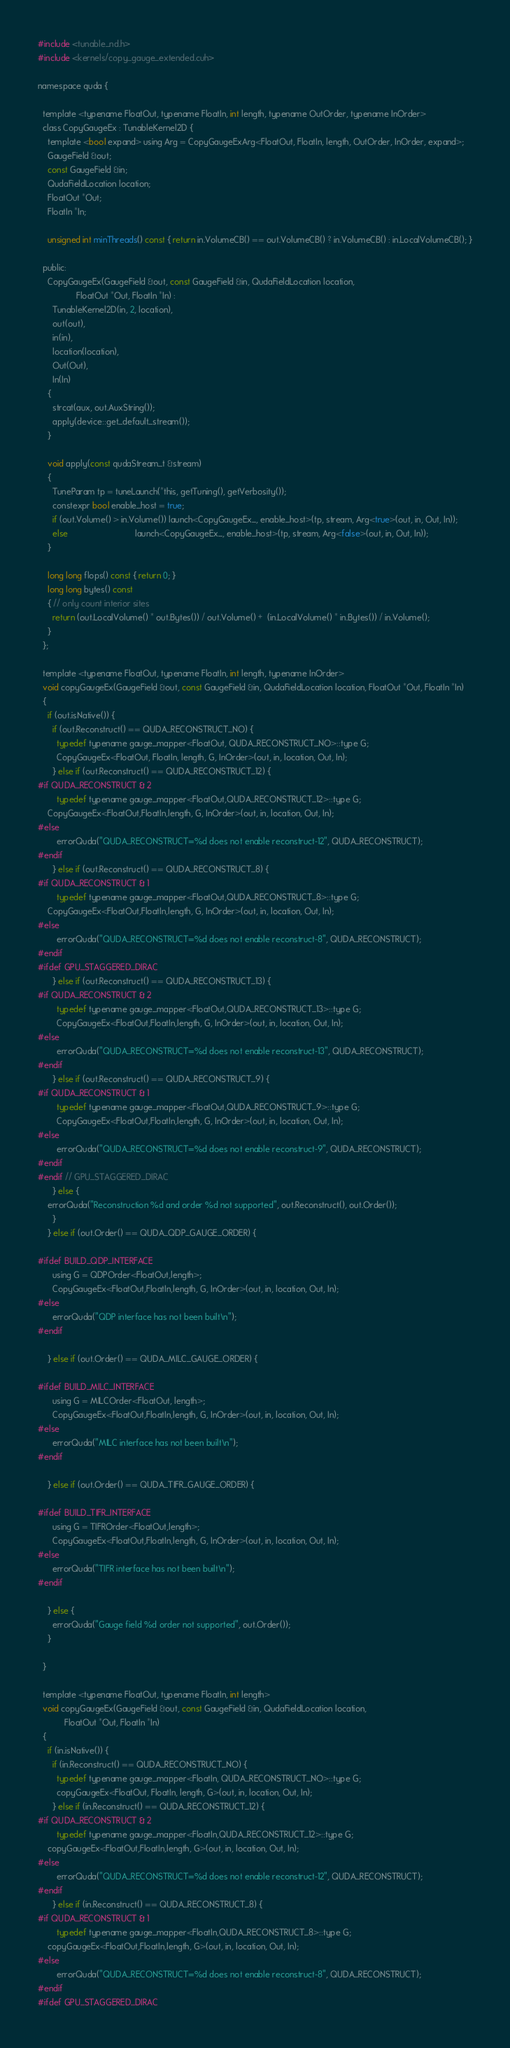Convert code to text. <code><loc_0><loc_0><loc_500><loc_500><_Cuda_>#include <tunable_nd.h>
#include <kernels/copy_gauge_extended.cuh>

namespace quda {

  template <typename FloatOut, typename FloatIn, int length, typename OutOrder, typename InOrder>
  class CopyGaugeEx : TunableKernel2D {
    template <bool expand> using Arg = CopyGaugeExArg<FloatOut, FloatIn, length, OutOrder, InOrder, expand>;
    GaugeField &out;
    const GaugeField &in;
    QudaFieldLocation location;
    FloatOut *Out;
    FloatIn *In;

    unsigned int minThreads() const { return in.VolumeCB() == out.VolumeCB() ? in.VolumeCB() : in.LocalVolumeCB(); }

  public:
    CopyGaugeEx(GaugeField &out, const GaugeField &in, QudaFieldLocation location,
                FloatOut *Out, FloatIn *In) :
      TunableKernel2D(in, 2, location),
      out(out),
      in(in),
      location(location),
      Out(Out),
      In(In)
    {
      strcat(aux, out.AuxString());
      apply(device::get_default_stream());
    }

    void apply(const qudaStream_t &stream)
    {
      TuneParam tp = tuneLaunch(*this, getTuning(), getVerbosity());
      constexpr bool enable_host = true;
      if (out.Volume() > in.Volume()) launch<CopyGaugeEx_, enable_host>(tp, stream, Arg<true>(out, in, Out, In));
      else                            launch<CopyGaugeEx_, enable_host>(tp, stream, Arg<false>(out, in, Out, In));
    }

    long long flops() const { return 0; }
    long long bytes() const
    { // only count interior sites
      return (out.LocalVolume() * out.Bytes()) / out.Volume() +  (in.LocalVolume() * in.Bytes()) / in.Volume();
    }
  };

  template <typename FloatOut, typename FloatIn, int length, typename InOrder>
  void copyGaugeEx(GaugeField &out, const GaugeField &in, QudaFieldLocation location, FloatOut *Out, FloatIn *In)
  {
    if (out.isNative()) {
      if (out.Reconstruct() == QUDA_RECONSTRUCT_NO) {
        typedef typename gauge_mapper<FloatOut, QUDA_RECONSTRUCT_NO>::type G;
        CopyGaugeEx<FloatOut, FloatIn, length, G, InOrder>(out, in, location, Out, In);
      } else if (out.Reconstruct() == QUDA_RECONSTRUCT_12) {
#if QUDA_RECONSTRUCT & 2
        typedef typename gauge_mapper<FloatOut,QUDA_RECONSTRUCT_12>::type G;
	CopyGaugeEx<FloatOut,FloatIn,length, G, InOrder>(out, in, location, Out, In);
#else
        errorQuda("QUDA_RECONSTRUCT=%d does not enable reconstruct-12", QUDA_RECONSTRUCT);
#endif
      } else if (out.Reconstruct() == QUDA_RECONSTRUCT_8) {
#if QUDA_RECONSTRUCT & 1
        typedef typename gauge_mapper<FloatOut,QUDA_RECONSTRUCT_8>::type G;
	CopyGaugeEx<FloatOut,FloatIn,length, G, InOrder>(out, in, location, Out, In);
#else
        errorQuda("QUDA_RECONSTRUCT=%d does not enable reconstruct-8", QUDA_RECONSTRUCT);
#endif
#ifdef GPU_STAGGERED_DIRAC
      } else if (out.Reconstruct() == QUDA_RECONSTRUCT_13) {
#if QUDA_RECONSTRUCT & 2
        typedef typename gauge_mapper<FloatOut,QUDA_RECONSTRUCT_13>::type G;
        CopyGaugeEx<FloatOut,FloatIn,length, G, InOrder>(out, in, location, Out, In);
#else
        errorQuda("QUDA_RECONSTRUCT=%d does not enable reconstruct-13", QUDA_RECONSTRUCT);
#endif
      } else if (out.Reconstruct() == QUDA_RECONSTRUCT_9) {
#if QUDA_RECONSTRUCT & 1
        typedef typename gauge_mapper<FloatOut,QUDA_RECONSTRUCT_9>::type G;
        CopyGaugeEx<FloatOut,FloatIn,length, G, InOrder>(out, in, location, Out, In);
#else
        errorQuda("QUDA_RECONSTRUCT=%d does not enable reconstruct-9", QUDA_RECONSTRUCT);
#endif
#endif // GPU_STAGGERED_DIRAC
      } else {
	errorQuda("Reconstruction %d and order %d not supported", out.Reconstruct(), out.Order());
      }
    } else if (out.Order() == QUDA_QDP_GAUGE_ORDER) {

#ifdef BUILD_QDP_INTERFACE
      using G = QDPOrder<FloatOut,length>;
      CopyGaugeEx<FloatOut,FloatIn,length, G, InOrder>(out, in, location, Out, In);
#else
      errorQuda("QDP interface has not been built\n");
#endif

    } else if (out.Order() == QUDA_MILC_GAUGE_ORDER) {

#ifdef BUILD_MILC_INTERFACE
      using G = MILCOrder<FloatOut, length>;
      CopyGaugeEx<FloatOut,FloatIn,length, G, InOrder>(out, in, location, Out, In);
#else
      errorQuda("MILC interface has not been built\n");
#endif

    } else if (out.Order() == QUDA_TIFR_GAUGE_ORDER) {

#ifdef BUILD_TIFR_INTERFACE
      using G = TIFROrder<FloatOut,length>;
      CopyGaugeEx<FloatOut,FloatIn,length, G, InOrder>(out, in, location, Out, In);
#else
      errorQuda("TIFR interface has not been built\n");
#endif

    } else {
      errorQuda("Gauge field %d order not supported", out.Order());
    }

  }

  template <typename FloatOut, typename FloatIn, int length>
  void copyGaugeEx(GaugeField &out, const GaugeField &in, QudaFieldLocation location,
		   FloatOut *Out, FloatIn *In)
  {
    if (in.isNative()) {
      if (in.Reconstruct() == QUDA_RECONSTRUCT_NO) {
        typedef typename gauge_mapper<FloatIn, QUDA_RECONSTRUCT_NO>::type G;
        copyGaugeEx<FloatOut, FloatIn, length, G>(out, in, location, Out, In);
      } else if (in.Reconstruct() == QUDA_RECONSTRUCT_12) {
#if QUDA_RECONSTRUCT & 2
        typedef typename gauge_mapper<FloatIn,QUDA_RECONSTRUCT_12>::type G;
	copyGaugeEx<FloatOut,FloatIn,length, G>(out, in, location, Out, In);
#else
        errorQuda("QUDA_RECONSTRUCT=%d does not enable reconstruct-12", QUDA_RECONSTRUCT);
#endif
      } else if (in.Reconstruct() == QUDA_RECONSTRUCT_8) {
#if QUDA_RECONSTRUCT & 1
        typedef typename gauge_mapper<FloatIn,QUDA_RECONSTRUCT_8>::type G;
	copyGaugeEx<FloatOut,FloatIn,length, G>(out, in, location, Out, In);
#else
        errorQuda("QUDA_RECONSTRUCT=%d does not enable reconstruct-8", QUDA_RECONSTRUCT);
#endif
#ifdef GPU_STAGGERED_DIRAC</code> 